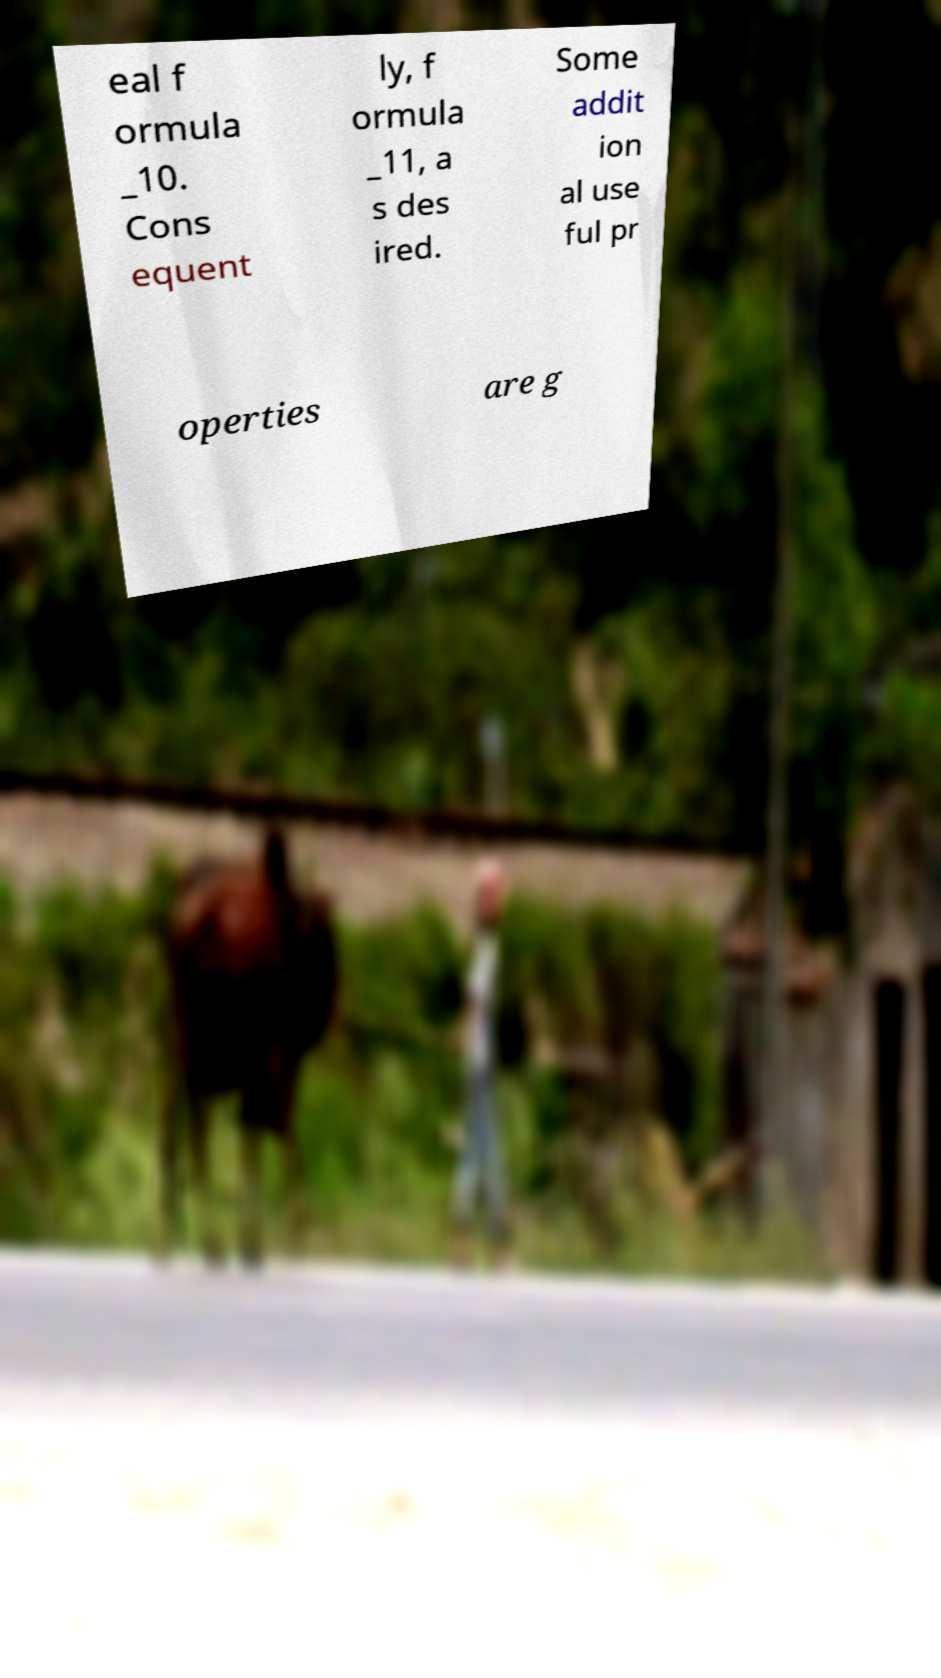What messages or text are displayed in this image? I need them in a readable, typed format. eal f ormula _10. Cons equent ly, f ormula _11, a s des ired. Some addit ion al use ful pr operties are g 